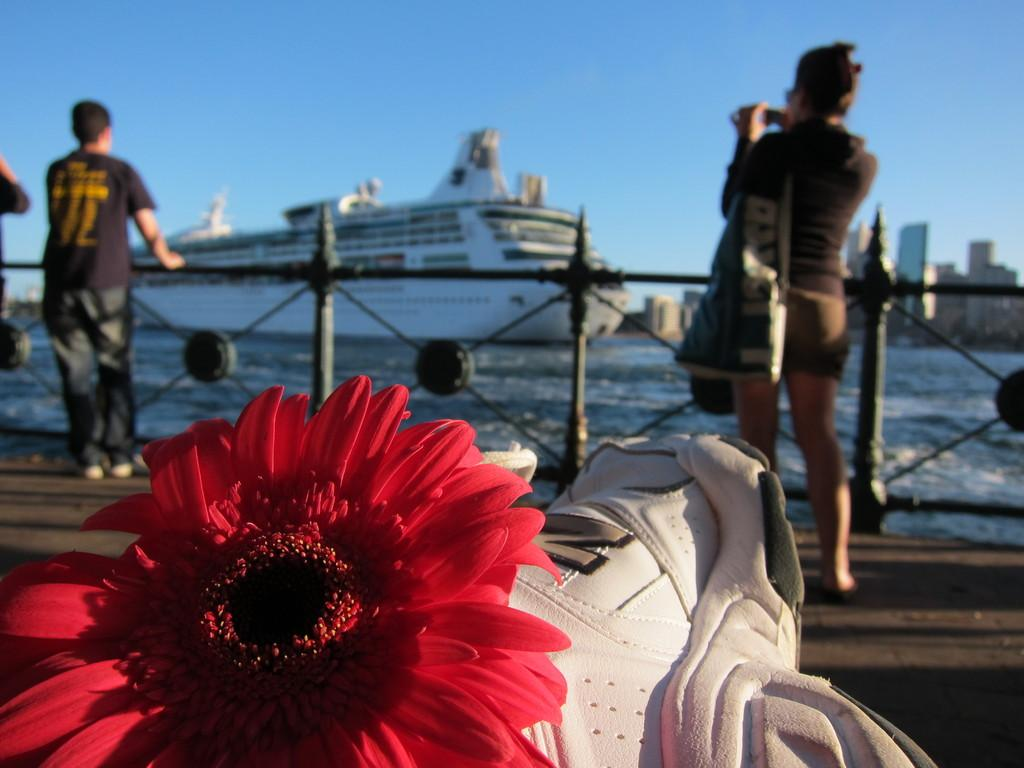What type of flower can be seen in the image? There is a red color flower in the image. Who or what is standing behind the railing? There are two members standing behind the railing. What is floating on the water in the image? A ship is floating on the water in the image. What can be seen in the background of the image? The sky is visible in the background of the image. How many patches are visible on the ship in the image? There are no patches visible on the ship in the image. Are there any bikes being ridden by the members standing behind the railing? There are no bikes present in the image. 